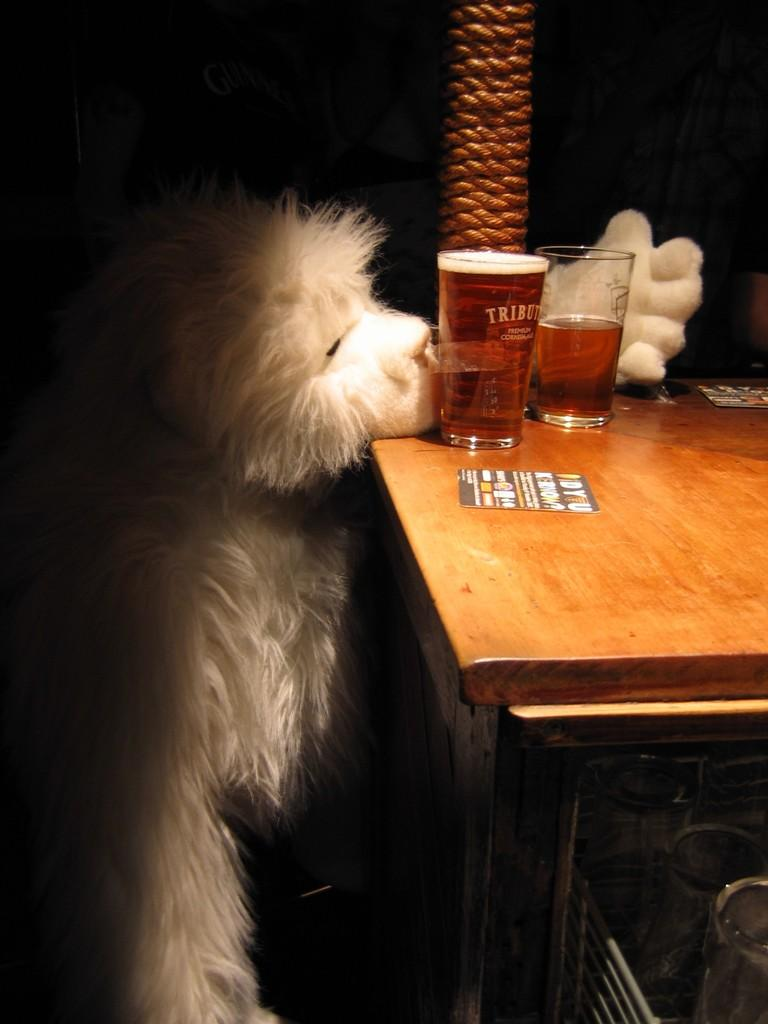What type of animal is present in the image? There is a dog in the image. What objects can be seen on the table in the image? There are two glasses on a table in the image. What type of curve can be seen on the dog's back in the image? There is no curve visible on the dog's back in the image. How many planes are visible in the image? There are no planes visible in the image. 